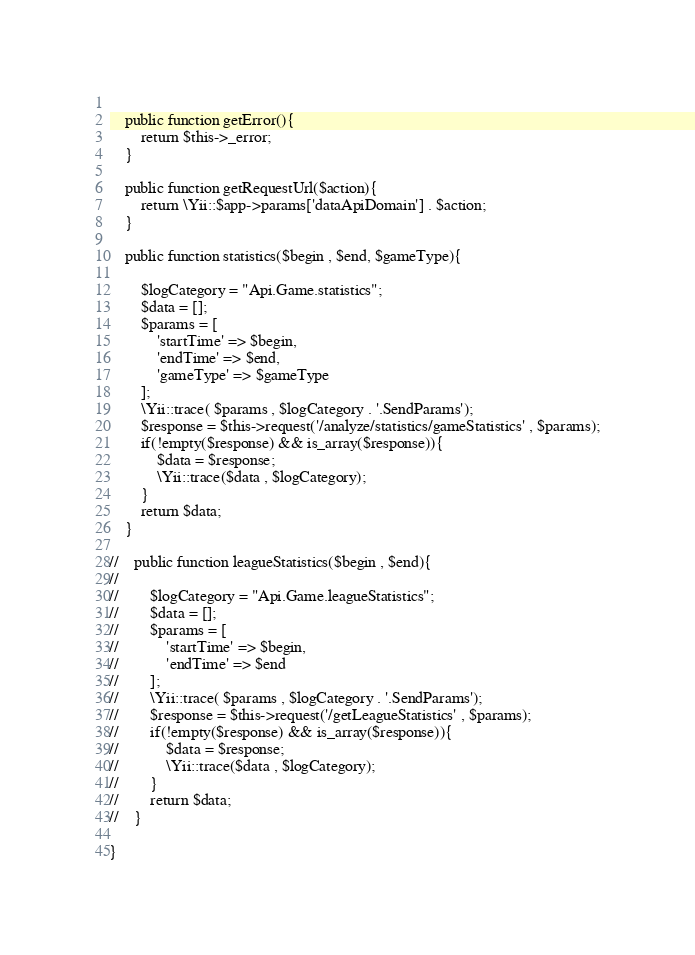<code> <loc_0><loc_0><loc_500><loc_500><_PHP_>    
    public function getError(){
        return $this->_error;
    }

    public function getRequestUrl($action){
        return \Yii::$app->params['dataApiDomain'] . $action;
    }
    
    public function statistics($begin , $end, $gameType){
        
        $logCategory = "Api.Game.statistics";
        $data = [];
        $params = [
            'startTime' => $begin,
            'endTime' => $end,
            'gameType' => $gameType
        ];
        \Yii::trace( $params , $logCategory . '.SendParams');
        $response = $this->request('/analyze/statistics/gameStatistics' , $params);
        if(!empty($response) && is_array($response)){
            $data = $response;
            \Yii::trace($data , $logCategory);
        }
        return $data;
    }

//    public function leagueStatistics($begin , $end){
//
//        $logCategory = "Api.Game.leagueStatistics";
//        $data = [];
//        $params = [
//            'startTime' => $begin,
//            'endTime' => $end
//        ];
//        \Yii::trace( $params , $logCategory . '.SendParams');
//        $response = $this->request('/getLeagueStatistics' , $params);
//        if(!empty($response) && is_array($response)){
//            $data = $response;
//            \Yii::trace($data , $logCategory);
//        }
//        return $data;
//    }
    
}</code> 